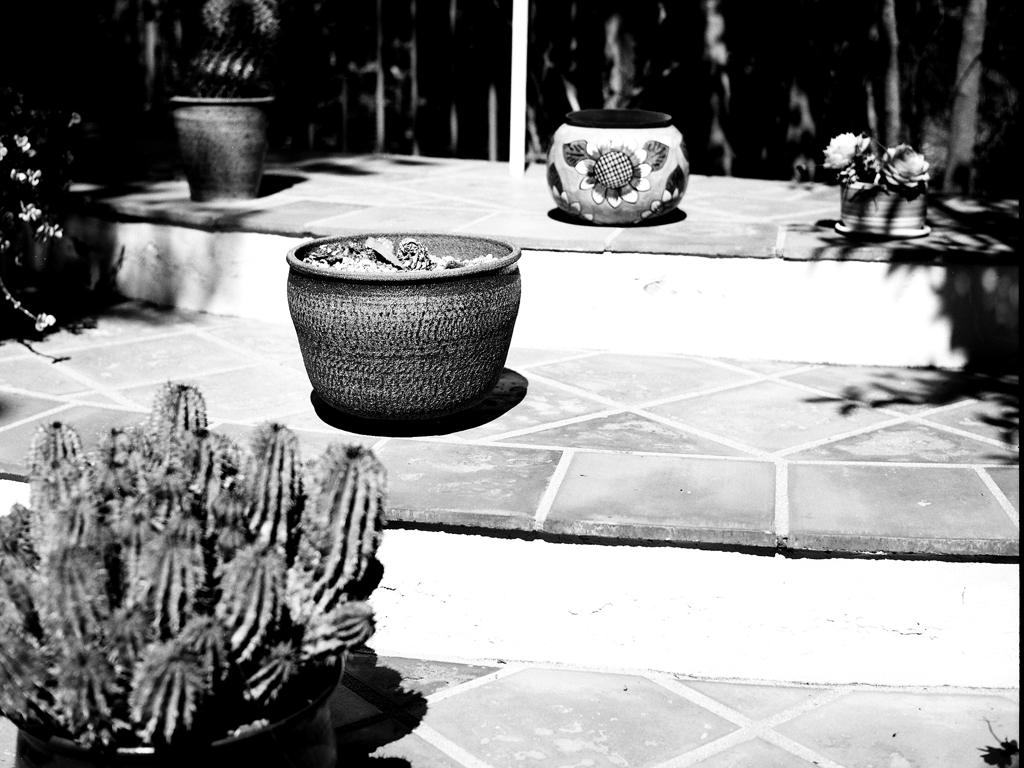What might be the best time of day to capture an image like this with natural light? The best time of day to capture an image with natural light that highlights texture and minimizes harsh shadows would be during the golden hours—shortly after sunrise or before sunset. During these times, the sun is low in the sky, producing a softer, diffused light. For this particular scene, early morning or late afternoon would provide gentle illumination that could reveal more detail in the plants' textures and the patio's surface. 